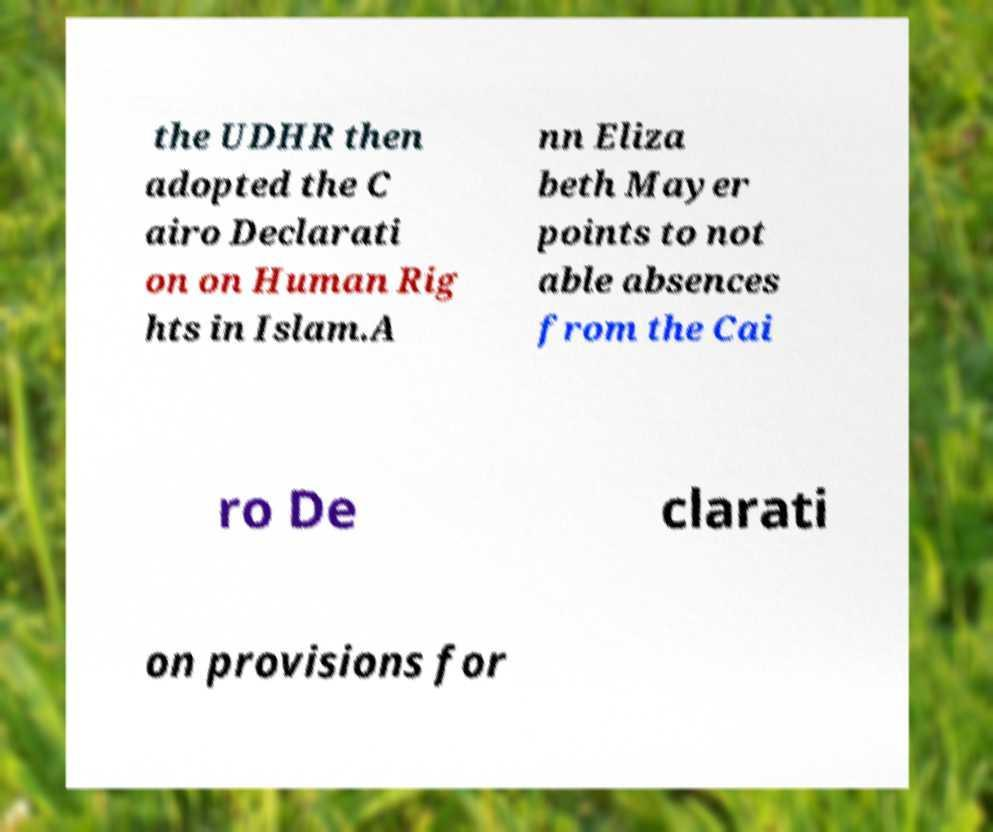For documentation purposes, I need the text within this image transcribed. Could you provide that? the UDHR then adopted the C airo Declarati on on Human Rig hts in Islam.A nn Eliza beth Mayer points to not able absences from the Cai ro De clarati on provisions for 